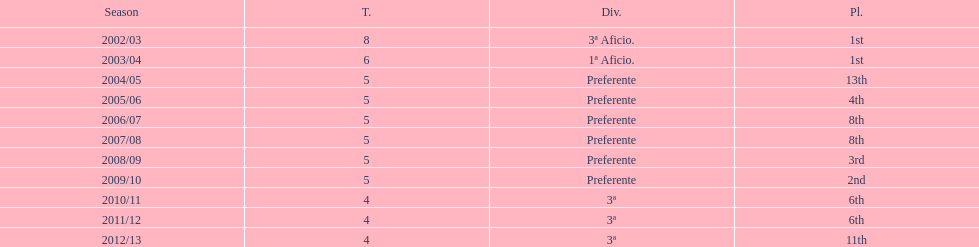How many years was the team in the 3 a division? 4. 